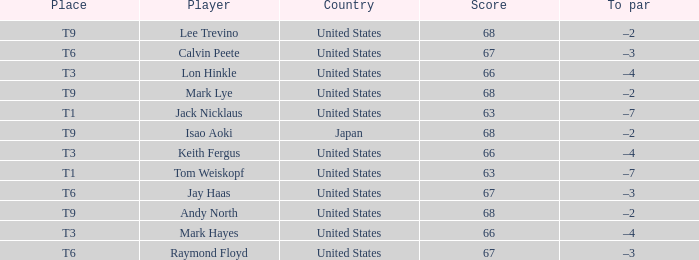Could you help me parse every detail presented in this table? {'header': ['Place', 'Player', 'Country', 'Score', 'To par'], 'rows': [['T9', 'Lee Trevino', 'United States', '68', '–2'], ['T6', 'Calvin Peete', 'United States', '67', '–3'], ['T3', 'Lon Hinkle', 'United States', '66', '–4'], ['T9', 'Mark Lye', 'United States', '68', '–2'], ['T1', 'Jack Nicklaus', 'United States', '63', '–7'], ['T9', 'Isao Aoki', 'Japan', '68', '–2'], ['T3', 'Keith Fergus', 'United States', '66', '–4'], ['T1', 'Tom Weiskopf', 'United States', '63', '–7'], ['T6', 'Jay Haas', 'United States', '67', '–3'], ['T9', 'Andy North', 'United States', '68', '–2'], ['T3', 'Mark Hayes', 'United States', '66', '–4'], ['T6', 'Raymond Floyd', 'United States', '67', '–3']]} What does to par signify when the player is "lee trevino" and the place is "t9"? –2. 